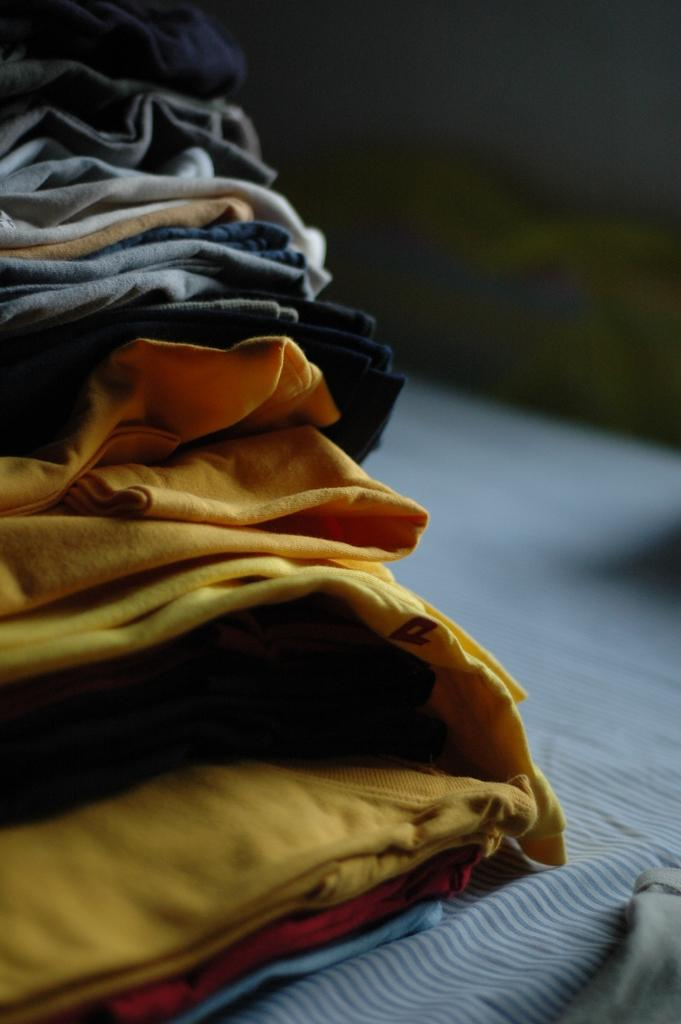What is the state of the clothes in the image? The clothes are folded in the image. What is the clothes placed on? The folded clothes are placed on a white cloth. How would you describe the background of the image? The background of the image is dark and blurred. What type of society is depicted in the image? There is no society depicted in the image; it only shows folded clothes on a white cloth with a dark and blurred background. 